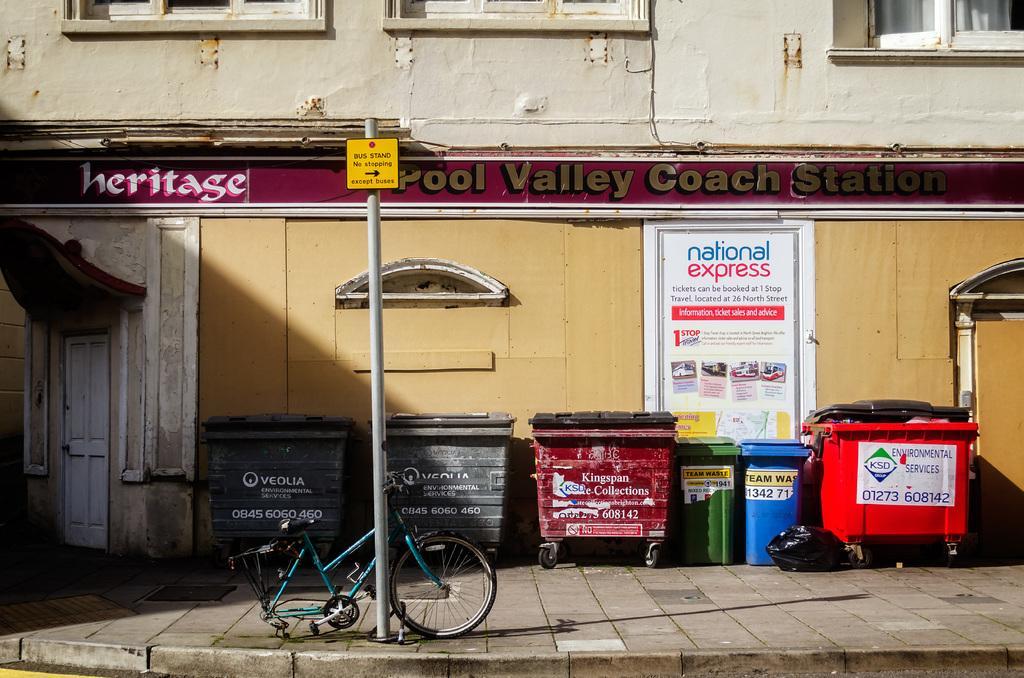Please provide a concise description of this image. In this image we can see a pole with a board and there is a bicycle and we can see some bins and other objects on the sidewalk and there is a board attached to the wall with some text and there is a building with doors and windows and there is a board with some text. 